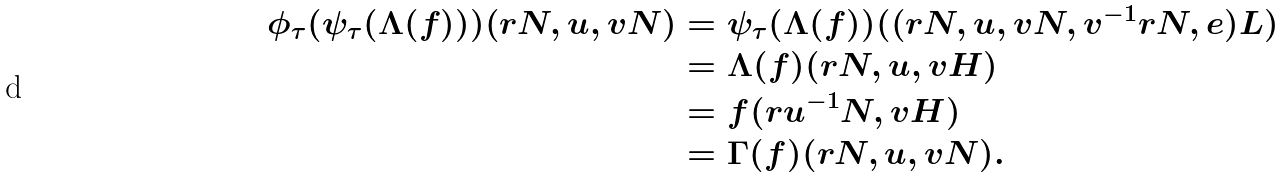<formula> <loc_0><loc_0><loc_500><loc_500>\phi _ { \tau } ( \psi _ { \tau } ( \Lambda ( f ) ) ) ( r N , u , v N ) & = \psi _ { \tau } ( \Lambda ( f ) ) ( ( r N , u , v N , v ^ { - 1 } r N , e ) L ) \\ & = \Lambda ( f ) ( r N , u , v H ) \\ & = f ( r u ^ { - 1 } N , v H ) \\ & = \Gamma ( f ) ( r N , u , v N ) .</formula> 